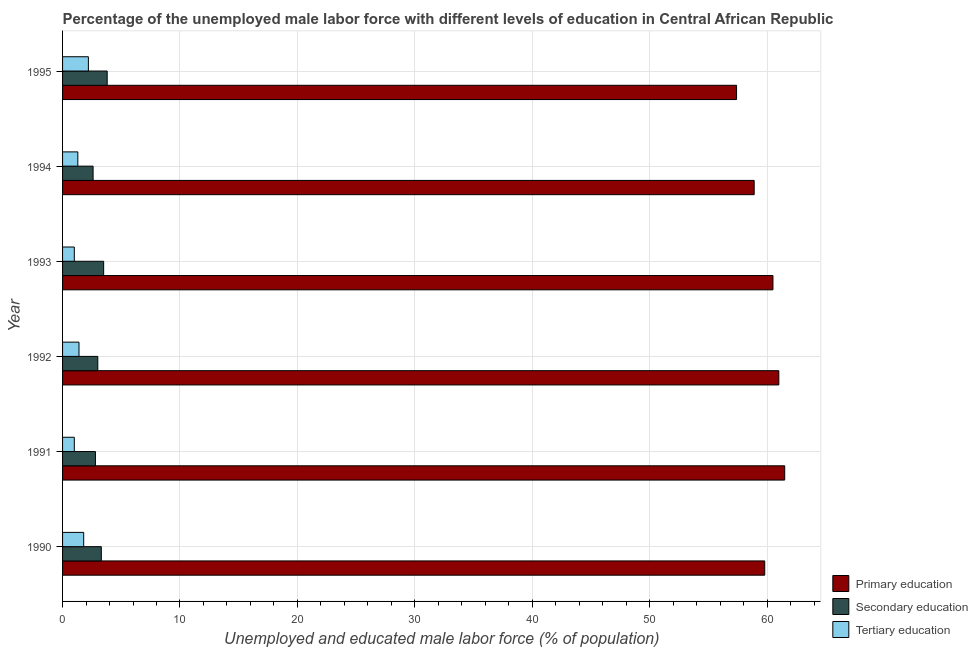How many different coloured bars are there?
Your response must be concise. 3. Are the number of bars on each tick of the Y-axis equal?
Ensure brevity in your answer.  Yes. In how many cases, is the number of bars for a given year not equal to the number of legend labels?
Provide a short and direct response. 0. What is the percentage of male labor force who received primary education in 1991?
Ensure brevity in your answer.  61.5. Across all years, what is the maximum percentage of male labor force who received secondary education?
Your answer should be very brief. 3.8. Across all years, what is the minimum percentage of male labor force who received primary education?
Your answer should be very brief. 57.4. In which year was the percentage of male labor force who received secondary education maximum?
Your answer should be very brief. 1995. In which year was the percentage of male labor force who received secondary education minimum?
Your response must be concise. 1994. What is the total percentage of male labor force who received primary education in the graph?
Your answer should be very brief. 359.1. What is the difference between the percentage of male labor force who received primary education in 1992 and that in 1994?
Make the answer very short. 2.1. What is the difference between the percentage of male labor force who received secondary education in 1993 and the percentage of male labor force who received primary education in 1995?
Keep it short and to the point. -53.9. What is the average percentage of male labor force who received secondary education per year?
Ensure brevity in your answer.  3.17. In the year 1995, what is the difference between the percentage of male labor force who received primary education and percentage of male labor force who received secondary education?
Provide a short and direct response. 53.6. In how many years, is the percentage of male labor force who received primary education greater than 2 %?
Your response must be concise. 6. What is the ratio of the percentage of male labor force who received tertiary education in 1993 to that in 1995?
Provide a short and direct response. 0.46. Is the difference between the percentage of male labor force who received secondary education in 1992 and 1995 greater than the difference between the percentage of male labor force who received tertiary education in 1992 and 1995?
Ensure brevity in your answer.  Yes. What is the difference between the highest and the second highest percentage of male labor force who received secondary education?
Provide a short and direct response. 0.3. What is the difference between the highest and the lowest percentage of male labor force who received primary education?
Provide a short and direct response. 4.1. In how many years, is the percentage of male labor force who received tertiary education greater than the average percentage of male labor force who received tertiary education taken over all years?
Make the answer very short. 2. Is the sum of the percentage of male labor force who received primary education in 1990 and 1991 greater than the maximum percentage of male labor force who received secondary education across all years?
Give a very brief answer. Yes. What does the 1st bar from the top in 1990 represents?
Offer a very short reply. Tertiary education. What does the 1st bar from the bottom in 1994 represents?
Offer a very short reply. Primary education. Does the graph contain grids?
Make the answer very short. Yes. Where does the legend appear in the graph?
Your response must be concise. Bottom right. How many legend labels are there?
Offer a terse response. 3. What is the title of the graph?
Offer a very short reply. Percentage of the unemployed male labor force with different levels of education in Central African Republic. What is the label or title of the X-axis?
Keep it short and to the point. Unemployed and educated male labor force (% of population). What is the label or title of the Y-axis?
Provide a succinct answer. Year. What is the Unemployed and educated male labor force (% of population) of Primary education in 1990?
Offer a terse response. 59.8. What is the Unemployed and educated male labor force (% of population) in Secondary education in 1990?
Provide a succinct answer. 3.3. What is the Unemployed and educated male labor force (% of population) in Tertiary education in 1990?
Your answer should be very brief. 1.8. What is the Unemployed and educated male labor force (% of population) of Primary education in 1991?
Offer a terse response. 61.5. What is the Unemployed and educated male labor force (% of population) in Secondary education in 1991?
Offer a terse response. 2.8. What is the Unemployed and educated male labor force (% of population) in Secondary education in 1992?
Your answer should be compact. 3. What is the Unemployed and educated male labor force (% of population) in Tertiary education in 1992?
Keep it short and to the point. 1.4. What is the Unemployed and educated male labor force (% of population) in Primary education in 1993?
Your response must be concise. 60.5. What is the Unemployed and educated male labor force (% of population) of Secondary education in 1993?
Make the answer very short. 3.5. What is the Unemployed and educated male labor force (% of population) of Tertiary education in 1993?
Provide a succinct answer. 1. What is the Unemployed and educated male labor force (% of population) in Primary education in 1994?
Your answer should be compact. 58.9. What is the Unemployed and educated male labor force (% of population) of Secondary education in 1994?
Your response must be concise. 2.6. What is the Unemployed and educated male labor force (% of population) of Tertiary education in 1994?
Your answer should be compact. 1.3. What is the Unemployed and educated male labor force (% of population) in Primary education in 1995?
Offer a very short reply. 57.4. What is the Unemployed and educated male labor force (% of population) in Secondary education in 1995?
Your response must be concise. 3.8. What is the Unemployed and educated male labor force (% of population) in Tertiary education in 1995?
Provide a short and direct response. 2.2. Across all years, what is the maximum Unemployed and educated male labor force (% of population) of Primary education?
Provide a short and direct response. 61.5. Across all years, what is the maximum Unemployed and educated male labor force (% of population) of Secondary education?
Your answer should be compact. 3.8. Across all years, what is the maximum Unemployed and educated male labor force (% of population) in Tertiary education?
Provide a short and direct response. 2.2. Across all years, what is the minimum Unemployed and educated male labor force (% of population) of Primary education?
Give a very brief answer. 57.4. Across all years, what is the minimum Unemployed and educated male labor force (% of population) of Secondary education?
Offer a terse response. 2.6. Across all years, what is the minimum Unemployed and educated male labor force (% of population) in Tertiary education?
Provide a short and direct response. 1. What is the total Unemployed and educated male labor force (% of population) in Primary education in the graph?
Make the answer very short. 359.1. What is the total Unemployed and educated male labor force (% of population) in Tertiary education in the graph?
Provide a short and direct response. 8.7. What is the difference between the Unemployed and educated male labor force (% of population) of Tertiary education in 1990 and that in 1992?
Your answer should be very brief. 0.4. What is the difference between the Unemployed and educated male labor force (% of population) in Tertiary education in 1990 and that in 1993?
Provide a short and direct response. 0.8. What is the difference between the Unemployed and educated male labor force (% of population) of Primary education in 1990 and that in 1994?
Your answer should be compact. 0.9. What is the difference between the Unemployed and educated male labor force (% of population) in Secondary education in 1990 and that in 1994?
Provide a succinct answer. 0.7. What is the difference between the Unemployed and educated male labor force (% of population) in Primary education in 1990 and that in 1995?
Your answer should be very brief. 2.4. What is the difference between the Unemployed and educated male labor force (% of population) of Secondary education in 1990 and that in 1995?
Your answer should be very brief. -0.5. What is the difference between the Unemployed and educated male labor force (% of population) of Tertiary education in 1990 and that in 1995?
Provide a short and direct response. -0.4. What is the difference between the Unemployed and educated male labor force (% of population) of Primary education in 1991 and that in 1992?
Keep it short and to the point. 0.5. What is the difference between the Unemployed and educated male labor force (% of population) in Tertiary education in 1991 and that in 1993?
Make the answer very short. 0. What is the difference between the Unemployed and educated male labor force (% of population) in Secondary education in 1991 and that in 1994?
Your answer should be very brief. 0.2. What is the difference between the Unemployed and educated male labor force (% of population) in Tertiary education in 1991 and that in 1994?
Give a very brief answer. -0.3. What is the difference between the Unemployed and educated male labor force (% of population) of Secondary education in 1991 and that in 1995?
Give a very brief answer. -1. What is the difference between the Unemployed and educated male labor force (% of population) of Tertiary education in 1992 and that in 1993?
Offer a very short reply. 0.4. What is the difference between the Unemployed and educated male labor force (% of population) in Secondary education in 1992 and that in 1994?
Your answer should be very brief. 0.4. What is the difference between the Unemployed and educated male labor force (% of population) in Tertiary education in 1992 and that in 1994?
Provide a short and direct response. 0.1. What is the difference between the Unemployed and educated male labor force (% of population) of Primary education in 1992 and that in 1995?
Provide a short and direct response. 3.6. What is the difference between the Unemployed and educated male labor force (% of population) of Secondary education in 1992 and that in 1995?
Your answer should be compact. -0.8. What is the difference between the Unemployed and educated male labor force (% of population) in Tertiary education in 1992 and that in 1995?
Offer a terse response. -0.8. What is the difference between the Unemployed and educated male labor force (% of population) of Primary education in 1993 and that in 1995?
Offer a terse response. 3.1. What is the difference between the Unemployed and educated male labor force (% of population) in Tertiary education in 1993 and that in 1995?
Your answer should be very brief. -1.2. What is the difference between the Unemployed and educated male labor force (% of population) in Primary education in 1994 and that in 1995?
Ensure brevity in your answer.  1.5. What is the difference between the Unemployed and educated male labor force (% of population) of Tertiary education in 1994 and that in 1995?
Keep it short and to the point. -0.9. What is the difference between the Unemployed and educated male labor force (% of population) of Primary education in 1990 and the Unemployed and educated male labor force (% of population) of Secondary education in 1991?
Offer a terse response. 57. What is the difference between the Unemployed and educated male labor force (% of population) of Primary education in 1990 and the Unemployed and educated male labor force (% of population) of Tertiary education in 1991?
Provide a succinct answer. 58.8. What is the difference between the Unemployed and educated male labor force (% of population) in Secondary education in 1990 and the Unemployed and educated male labor force (% of population) in Tertiary education in 1991?
Give a very brief answer. 2.3. What is the difference between the Unemployed and educated male labor force (% of population) in Primary education in 1990 and the Unemployed and educated male labor force (% of population) in Secondary education in 1992?
Your answer should be compact. 56.8. What is the difference between the Unemployed and educated male labor force (% of population) in Primary education in 1990 and the Unemployed and educated male labor force (% of population) in Tertiary education in 1992?
Keep it short and to the point. 58.4. What is the difference between the Unemployed and educated male labor force (% of population) of Primary education in 1990 and the Unemployed and educated male labor force (% of population) of Secondary education in 1993?
Ensure brevity in your answer.  56.3. What is the difference between the Unemployed and educated male labor force (% of population) in Primary education in 1990 and the Unemployed and educated male labor force (% of population) in Tertiary education in 1993?
Provide a succinct answer. 58.8. What is the difference between the Unemployed and educated male labor force (% of population) in Secondary education in 1990 and the Unemployed and educated male labor force (% of population) in Tertiary education in 1993?
Ensure brevity in your answer.  2.3. What is the difference between the Unemployed and educated male labor force (% of population) in Primary education in 1990 and the Unemployed and educated male labor force (% of population) in Secondary education in 1994?
Make the answer very short. 57.2. What is the difference between the Unemployed and educated male labor force (% of population) of Primary education in 1990 and the Unemployed and educated male labor force (% of population) of Tertiary education in 1994?
Ensure brevity in your answer.  58.5. What is the difference between the Unemployed and educated male labor force (% of population) of Secondary education in 1990 and the Unemployed and educated male labor force (% of population) of Tertiary education in 1994?
Give a very brief answer. 2. What is the difference between the Unemployed and educated male labor force (% of population) of Primary education in 1990 and the Unemployed and educated male labor force (% of population) of Secondary education in 1995?
Provide a short and direct response. 56. What is the difference between the Unemployed and educated male labor force (% of population) in Primary education in 1990 and the Unemployed and educated male labor force (% of population) in Tertiary education in 1995?
Offer a terse response. 57.6. What is the difference between the Unemployed and educated male labor force (% of population) of Primary education in 1991 and the Unemployed and educated male labor force (% of population) of Secondary education in 1992?
Give a very brief answer. 58.5. What is the difference between the Unemployed and educated male labor force (% of population) in Primary education in 1991 and the Unemployed and educated male labor force (% of population) in Tertiary education in 1992?
Your response must be concise. 60.1. What is the difference between the Unemployed and educated male labor force (% of population) of Secondary education in 1991 and the Unemployed and educated male labor force (% of population) of Tertiary education in 1992?
Your response must be concise. 1.4. What is the difference between the Unemployed and educated male labor force (% of population) in Primary education in 1991 and the Unemployed and educated male labor force (% of population) in Tertiary education in 1993?
Your answer should be very brief. 60.5. What is the difference between the Unemployed and educated male labor force (% of population) in Primary education in 1991 and the Unemployed and educated male labor force (% of population) in Secondary education in 1994?
Provide a short and direct response. 58.9. What is the difference between the Unemployed and educated male labor force (% of population) in Primary education in 1991 and the Unemployed and educated male labor force (% of population) in Tertiary education in 1994?
Make the answer very short. 60.2. What is the difference between the Unemployed and educated male labor force (% of population) of Primary education in 1991 and the Unemployed and educated male labor force (% of population) of Secondary education in 1995?
Offer a very short reply. 57.7. What is the difference between the Unemployed and educated male labor force (% of population) in Primary education in 1991 and the Unemployed and educated male labor force (% of population) in Tertiary education in 1995?
Give a very brief answer. 59.3. What is the difference between the Unemployed and educated male labor force (% of population) in Secondary education in 1991 and the Unemployed and educated male labor force (% of population) in Tertiary education in 1995?
Your response must be concise. 0.6. What is the difference between the Unemployed and educated male labor force (% of population) in Primary education in 1992 and the Unemployed and educated male labor force (% of population) in Secondary education in 1993?
Your answer should be compact. 57.5. What is the difference between the Unemployed and educated male labor force (% of population) of Primary education in 1992 and the Unemployed and educated male labor force (% of population) of Tertiary education in 1993?
Offer a very short reply. 60. What is the difference between the Unemployed and educated male labor force (% of population) of Secondary education in 1992 and the Unemployed and educated male labor force (% of population) of Tertiary education in 1993?
Provide a short and direct response. 2. What is the difference between the Unemployed and educated male labor force (% of population) of Primary education in 1992 and the Unemployed and educated male labor force (% of population) of Secondary education in 1994?
Provide a succinct answer. 58.4. What is the difference between the Unemployed and educated male labor force (% of population) in Primary education in 1992 and the Unemployed and educated male labor force (% of population) in Tertiary education in 1994?
Provide a succinct answer. 59.7. What is the difference between the Unemployed and educated male labor force (% of population) in Secondary education in 1992 and the Unemployed and educated male labor force (% of population) in Tertiary education in 1994?
Your answer should be compact. 1.7. What is the difference between the Unemployed and educated male labor force (% of population) of Primary education in 1992 and the Unemployed and educated male labor force (% of population) of Secondary education in 1995?
Offer a terse response. 57.2. What is the difference between the Unemployed and educated male labor force (% of population) in Primary education in 1992 and the Unemployed and educated male labor force (% of population) in Tertiary education in 1995?
Your response must be concise. 58.8. What is the difference between the Unemployed and educated male labor force (% of population) of Secondary education in 1992 and the Unemployed and educated male labor force (% of population) of Tertiary education in 1995?
Your response must be concise. 0.8. What is the difference between the Unemployed and educated male labor force (% of population) of Primary education in 1993 and the Unemployed and educated male labor force (% of population) of Secondary education in 1994?
Provide a short and direct response. 57.9. What is the difference between the Unemployed and educated male labor force (% of population) of Primary education in 1993 and the Unemployed and educated male labor force (% of population) of Tertiary education in 1994?
Your response must be concise. 59.2. What is the difference between the Unemployed and educated male labor force (% of population) of Primary education in 1993 and the Unemployed and educated male labor force (% of population) of Secondary education in 1995?
Give a very brief answer. 56.7. What is the difference between the Unemployed and educated male labor force (% of population) in Primary education in 1993 and the Unemployed and educated male labor force (% of population) in Tertiary education in 1995?
Offer a very short reply. 58.3. What is the difference between the Unemployed and educated male labor force (% of population) in Secondary education in 1993 and the Unemployed and educated male labor force (% of population) in Tertiary education in 1995?
Give a very brief answer. 1.3. What is the difference between the Unemployed and educated male labor force (% of population) in Primary education in 1994 and the Unemployed and educated male labor force (% of population) in Secondary education in 1995?
Offer a very short reply. 55.1. What is the difference between the Unemployed and educated male labor force (% of population) in Primary education in 1994 and the Unemployed and educated male labor force (% of population) in Tertiary education in 1995?
Offer a terse response. 56.7. What is the average Unemployed and educated male labor force (% of population) of Primary education per year?
Your answer should be very brief. 59.85. What is the average Unemployed and educated male labor force (% of population) in Secondary education per year?
Make the answer very short. 3.17. What is the average Unemployed and educated male labor force (% of population) in Tertiary education per year?
Provide a short and direct response. 1.45. In the year 1990, what is the difference between the Unemployed and educated male labor force (% of population) in Primary education and Unemployed and educated male labor force (% of population) in Secondary education?
Offer a terse response. 56.5. In the year 1990, what is the difference between the Unemployed and educated male labor force (% of population) of Primary education and Unemployed and educated male labor force (% of population) of Tertiary education?
Provide a succinct answer. 58. In the year 1991, what is the difference between the Unemployed and educated male labor force (% of population) of Primary education and Unemployed and educated male labor force (% of population) of Secondary education?
Ensure brevity in your answer.  58.7. In the year 1991, what is the difference between the Unemployed and educated male labor force (% of population) in Primary education and Unemployed and educated male labor force (% of population) in Tertiary education?
Your response must be concise. 60.5. In the year 1991, what is the difference between the Unemployed and educated male labor force (% of population) in Secondary education and Unemployed and educated male labor force (% of population) in Tertiary education?
Provide a succinct answer. 1.8. In the year 1992, what is the difference between the Unemployed and educated male labor force (% of population) of Primary education and Unemployed and educated male labor force (% of population) of Tertiary education?
Your response must be concise. 59.6. In the year 1993, what is the difference between the Unemployed and educated male labor force (% of population) in Primary education and Unemployed and educated male labor force (% of population) in Tertiary education?
Your response must be concise. 59.5. In the year 1993, what is the difference between the Unemployed and educated male labor force (% of population) of Secondary education and Unemployed and educated male labor force (% of population) of Tertiary education?
Your answer should be very brief. 2.5. In the year 1994, what is the difference between the Unemployed and educated male labor force (% of population) of Primary education and Unemployed and educated male labor force (% of population) of Secondary education?
Provide a succinct answer. 56.3. In the year 1994, what is the difference between the Unemployed and educated male labor force (% of population) in Primary education and Unemployed and educated male labor force (% of population) in Tertiary education?
Provide a short and direct response. 57.6. In the year 1995, what is the difference between the Unemployed and educated male labor force (% of population) in Primary education and Unemployed and educated male labor force (% of population) in Secondary education?
Ensure brevity in your answer.  53.6. In the year 1995, what is the difference between the Unemployed and educated male labor force (% of population) of Primary education and Unemployed and educated male labor force (% of population) of Tertiary education?
Provide a succinct answer. 55.2. What is the ratio of the Unemployed and educated male labor force (% of population) in Primary education in 1990 to that in 1991?
Provide a short and direct response. 0.97. What is the ratio of the Unemployed and educated male labor force (% of population) of Secondary education in 1990 to that in 1991?
Offer a very short reply. 1.18. What is the ratio of the Unemployed and educated male labor force (% of population) in Primary education in 1990 to that in 1992?
Your answer should be very brief. 0.98. What is the ratio of the Unemployed and educated male labor force (% of population) of Primary education in 1990 to that in 1993?
Your answer should be very brief. 0.99. What is the ratio of the Unemployed and educated male labor force (% of population) in Secondary education in 1990 to that in 1993?
Give a very brief answer. 0.94. What is the ratio of the Unemployed and educated male labor force (% of population) of Primary education in 1990 to that in 1994?
Keep it short and to the point. 1.02. What is the ratio of the Unemployed and educated male labor force (% of population) in Secondary education in 1990 to that in 1994?
Provide a short and direct response. 1.27. What is the ratio of the Unemployed and educated male labor force (% of population) in Tertiary education in 1990 to that in 1994?
Ensure brevity in your answer.  1.38. What is the ratio of the Unemployed and educated male labor force (% of population) of Primary education in 1990 to that in 1995?
Offer a very short reply. 1.04. What is the ratio of the Unemployed and educated male labor force (% of population) in Secondary education in 1990 to that in 1995?
Ensure brevity in your answer.  0.87. What is the ratio of the Unemployed and educated male labor force (% of population) of Tertiary education in 1990 to that in 1995?
Ensure brevity in your answer.  0.82. What is the ratio of the Unemployed and educated male labor force (% of population) in Primary education in 1991 to that in 1992?
Offer a terse response. 1.01. What is the ratio of the Unemployed and educated male labor force (% of population) in Primary education in 1991 to that in 1993?
Provide a succinct answer. 1.02. What is the ratio of the Unemployed and educated male labor force (% of population) in Primary education in 1991 to that in 1994?
Keep it short and to the point. 1.04. What is the ratio of the Unemployed and educated male labor force (% of population) of Secondary education in 1991 to that in 1994?
Keep it short and to the point. 1.08. What is the ratio of the Unemployed and educated male labor force (% of population) of Tertiary education in 1991 to that in 1994?
Offer a terse response. 0.77. What is the ratio of the Unemployed and educated male labor force (% of population) of Primary education in 1991 to that in 1995?
Offer a very short reply. 1.07. What is the ratio of the Unemployed and educated male labor force (% of population) in Secondary education in 1991 to that in 1995?
Provide a short and direct response. 0.74. What is the ratio of the Unemployed and educated male labor force (% of population) in Tertiary education in 1991 to that in 1995?
Your answer should be compact. 0.45. What is the ratio of the Unemployed and educated male labor force (% of population) of Primary education in 1992 to that in 1993?
Your response must be concise. 1.01. What is the ratio of the Unemployed and educated male labor force (% of population) of Tertiary education in 1992 to that in 1993?
Offer a very short reply. 1.4. What is the ratio of the Unemployed and educated male labor force (% of population) in Primary education in 1992 to that in 1994?
Give a very brief answer. 1.04. What is the ratio of the Unemployed and educated male labor force (% of population) in Secondary education in 1992 to that in 1994?
Give a very brief answer. 1.15. What is the ratio of the Unemployed and educated male labor force (% of population) in Primary education in 1992 to that in 1995?
Your answer should be compact. 1.06. What is the ratio of the Unemployed and educated male labor force (% of population) in Secondary education in 1992 to that in 1995?
Ensure brevity in your answer.  0.79. What is the ratio of the Unemployed and educated male labor force (% of population) of Tertiary education in 1992 to that in 1995?
Your answer should be compact. 0.64. What is the ratio of the Unemployed and educated male labor force (% of population) in Primary education in 1993 to that in 1994?
Make the answer very short. 1.03. What is the ratio of the Unemployed and educated male labor force (% of population) of Secondary education in 1993 to that in 1994?
Keep it short and to the point. 1.35. What is the ratio of the Unemployed and educated male labor force (% of population) in Tertiary education in 1993 to that in 1994?
Your response must be concise. 0.77. What is the ratio of the Unemployed and educated male labor force (% of population) in Primary education in 1993 to that in 1995?
Provide a short and direct response. 1.05. What is the ratio of the Unemployed and educated male labor force (% of population) in Secondary education in 1993 to that in 1995?
Your answer should be very brief. 0.92. What is the ratio of the Unemployed and educated male labor force (% of population) of Tertiary education in 1993 to that in 1995?
Keep it short and to the point. 0.45. What is the ratio of the Unemployed and educated male labor force (% of population) of Primary education in 1994 to that in 1995?
Give a very brief answer. 1.03. What is the ratio of the Unemployed and educated male labor force (% of population) in Secondary education in 1994 to that in 1995?
Your response must be concise. 0.68. What is the ratio of the Unemployed and educated male labor force (% of population) of Tertiary education in 1994 to that in 1995?
Offer a very short reply. 0.59. What is the difference between the highest and the second highest Unemployed and educated male labor force (% of population) in Secondary education?
Your answer should be very brief. 0.3. What is the difference between the highest and the second highest Unemployed and educated male labor force (% of population) of Tertiary education?
Your answer should be compact. 0.4. What is the difference between the highest and the lowest Unemployed and educated male labor force (% of population) in Primary education?
Offer a terse response. 4.1. What is the difference between the highest and the lowest Unemployed and educated male labor force (% of population) of Secondary education?
Keep it short and to the point. 1.2. What is the difference between the highest and the lowest Unemployed and educated male labor force (% of population) of Tertiary education?
Give a very brief answer. 1.2. 